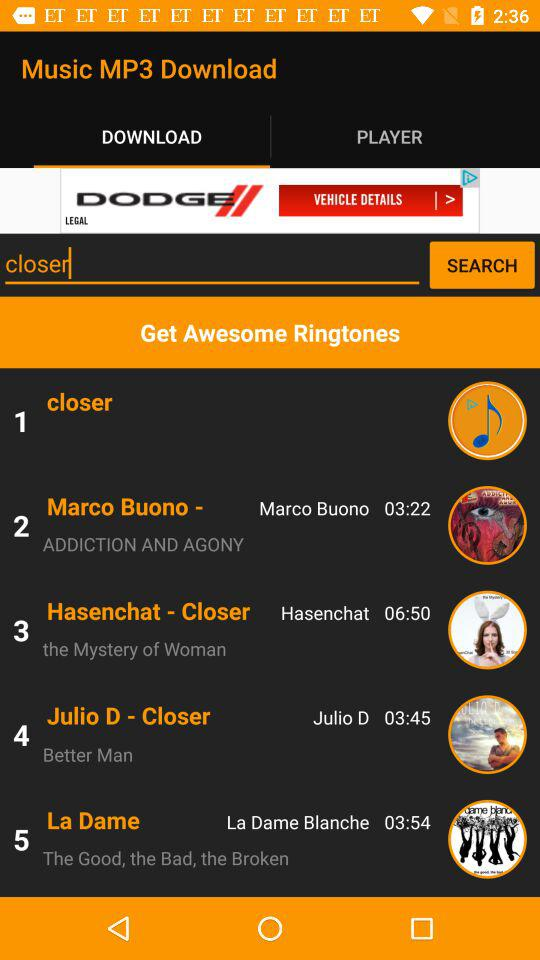What is the time duration of the song "Better Man"? The time duration is 3 minutes and 45 seconds. 